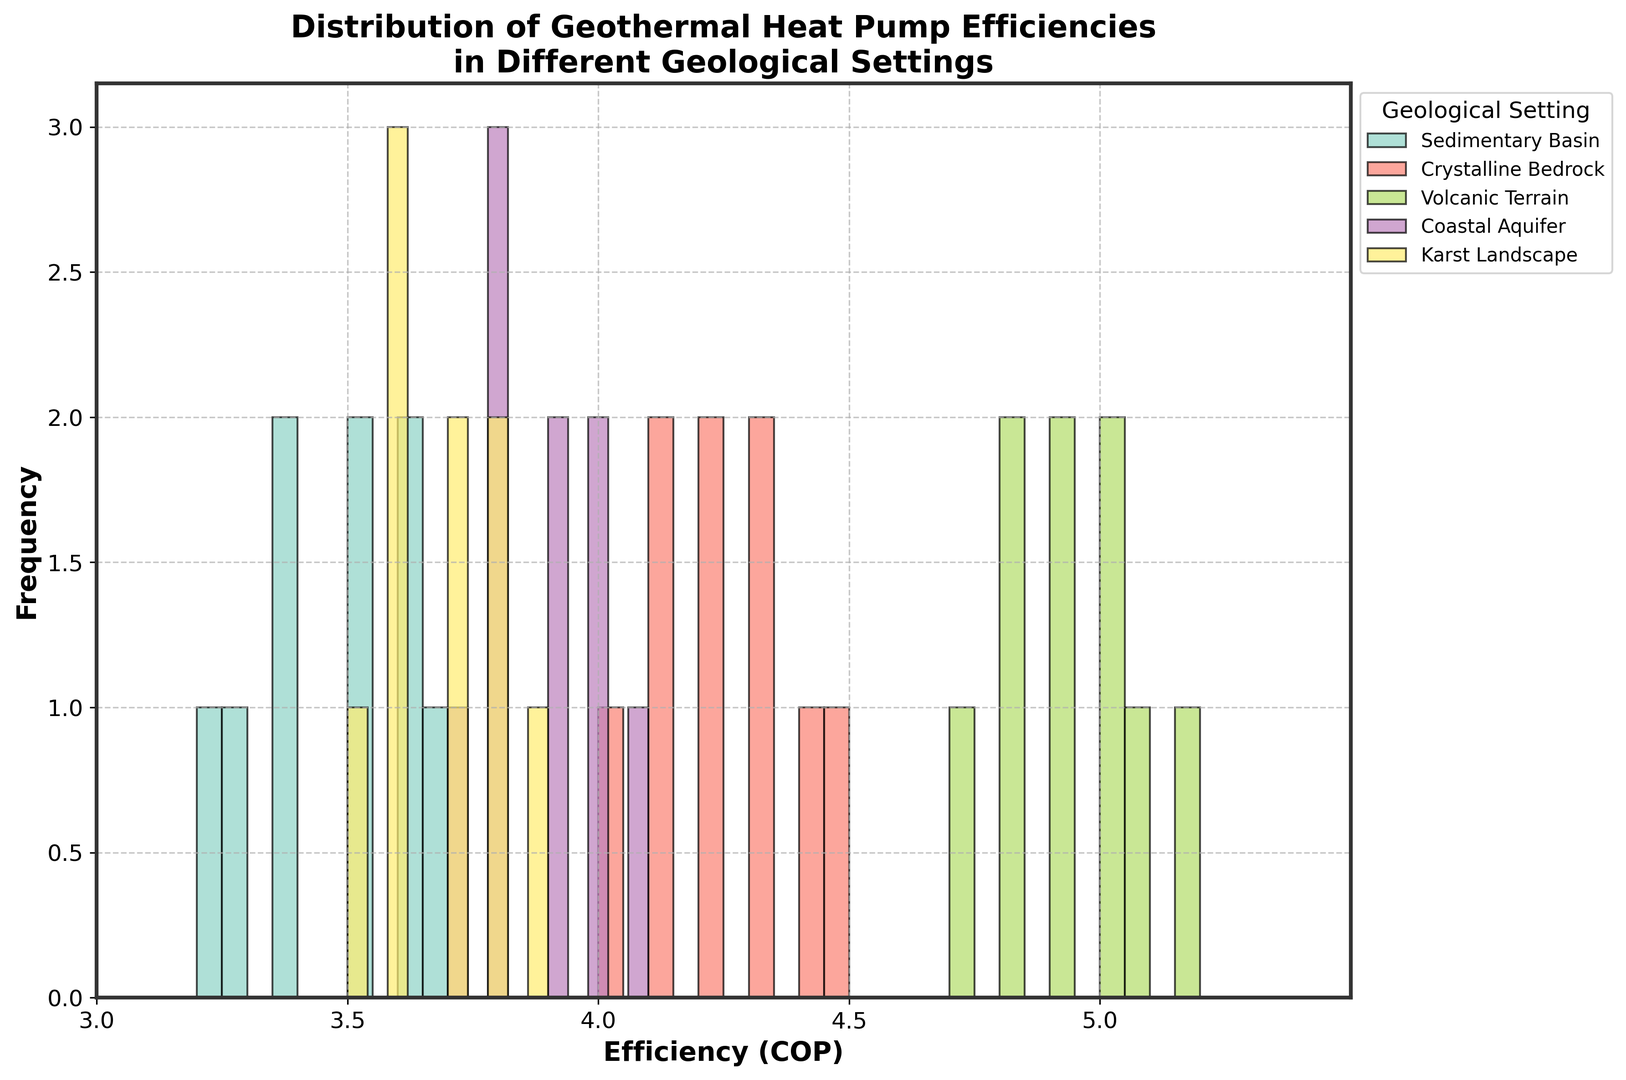Which geothermal setting has the highest efficiency range? The highest efficiency range corresponds to the tallest bars located furthest to the right on the x-axis. Volcanic Terrain has bars in the range of 4.7 to 5.2, which is higher than any other settings.
Answer: Volcanic Terrain Which geothermal setting has the lowest efficiency range? The lowest efficiency range corresponds to the shortest bars located furthest to the left on the x-axis. Sedimentary Basin has bars in the range of 3.2 to 3.7, which is lower than any other settings.
Answer: Sedimentary Basin What's the average efficiency of the Crystalline Bedrock setting? Add all the efficiencies within the Crystalline Bedrock group and divide by the number of data points. The sum of efficiencies is 4.1 + 4.3 + 4.2 + 4.4 + 4.0 + 4.2 + 4.3 + 4.1 + 4.5 = 37.1. There are 9 data points, so the average is 37.1 / 9 = 4.12.
Answer: 4.12 Which setting shows the most spread in efficiency values? The most spread will have the widest range on the x-axis. Volcanic Terrain spans from 4.7 to 5.2, indicating it has the largest spread compared to the other settings.
Answer: Volcanic Terrain Is there any setting with efficiency (COP) values exactly equal to 4.5? Check the histogram for any bars positioned at x-axis value 4.5. Only Crystalline Bedrock has a bar at 4.5.
Answer: Crystalline Bedrock Do Coastal Aquifers have more efficient geothermal pumps compared to Karst Landscapes? Compare the overall range and the height of the bars on the x-axis for both settings. Coastal Aquifer efficiencies range from 3.7 to 4.1, while Karst Landscapes range from 3.5 to 3.9. Coastal Aquifers generally have higher efficiency.
Answer: Coastal Aquifers What is the most common efficiency value range for Sedimentary Basin? Observe the tallest bar(s) within the Sedimentary Basin setting. The tallest bars are between 3.4 and 3.6, indicating the most common efficiency range.
Answer: 3.4-3.6 